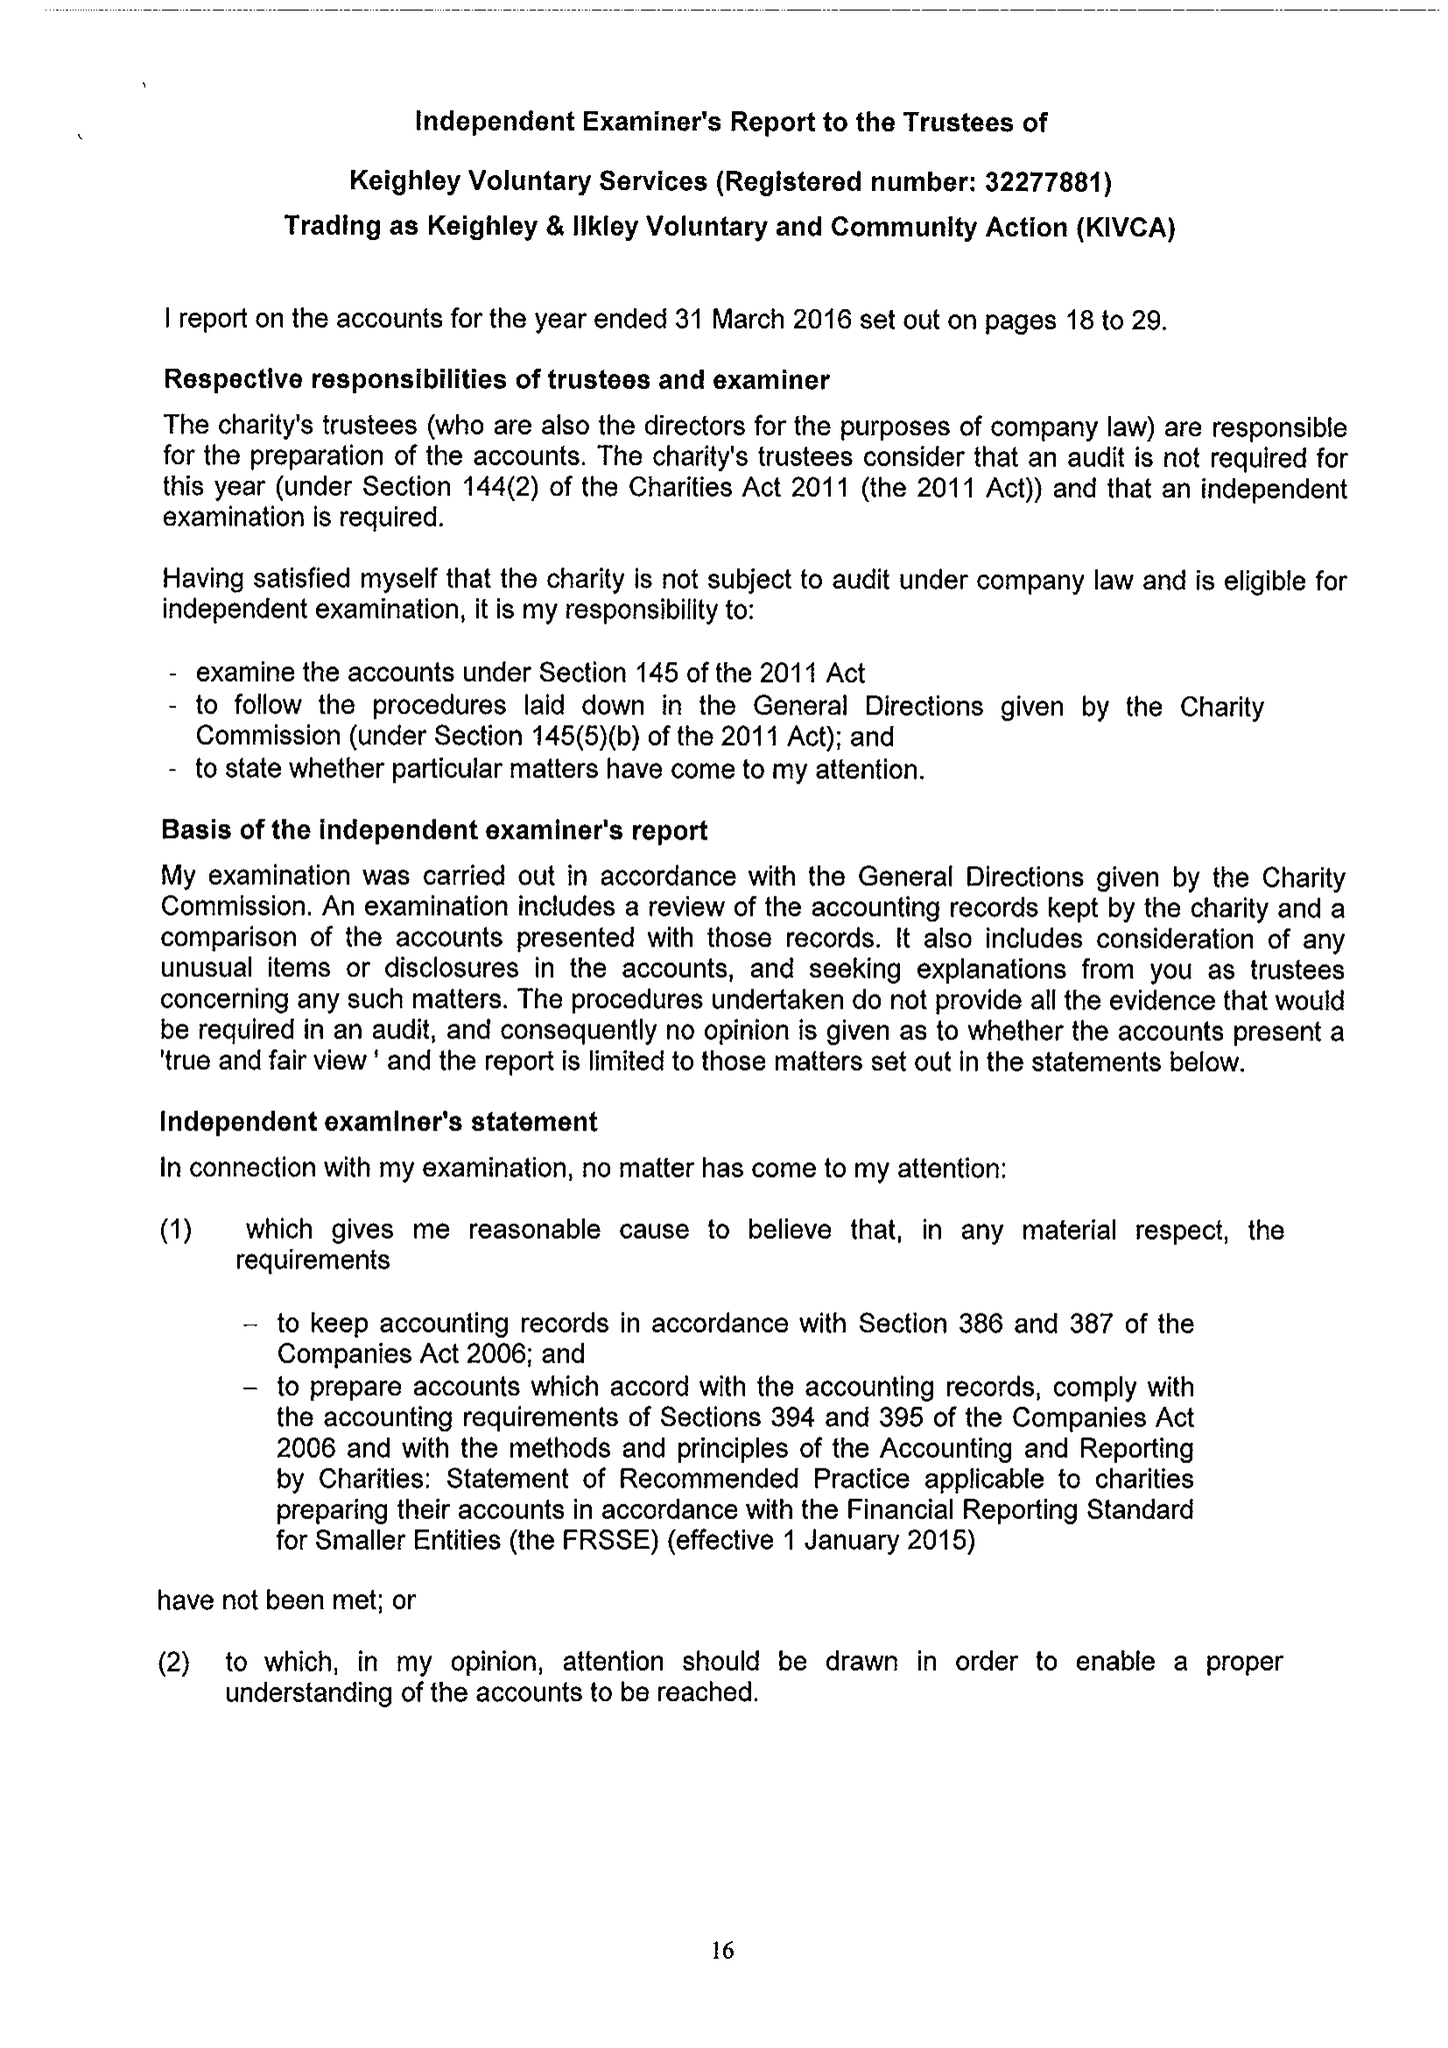What is the value for the address__postcode?
Answer the question using a single word or phrase. BD21 3JD 